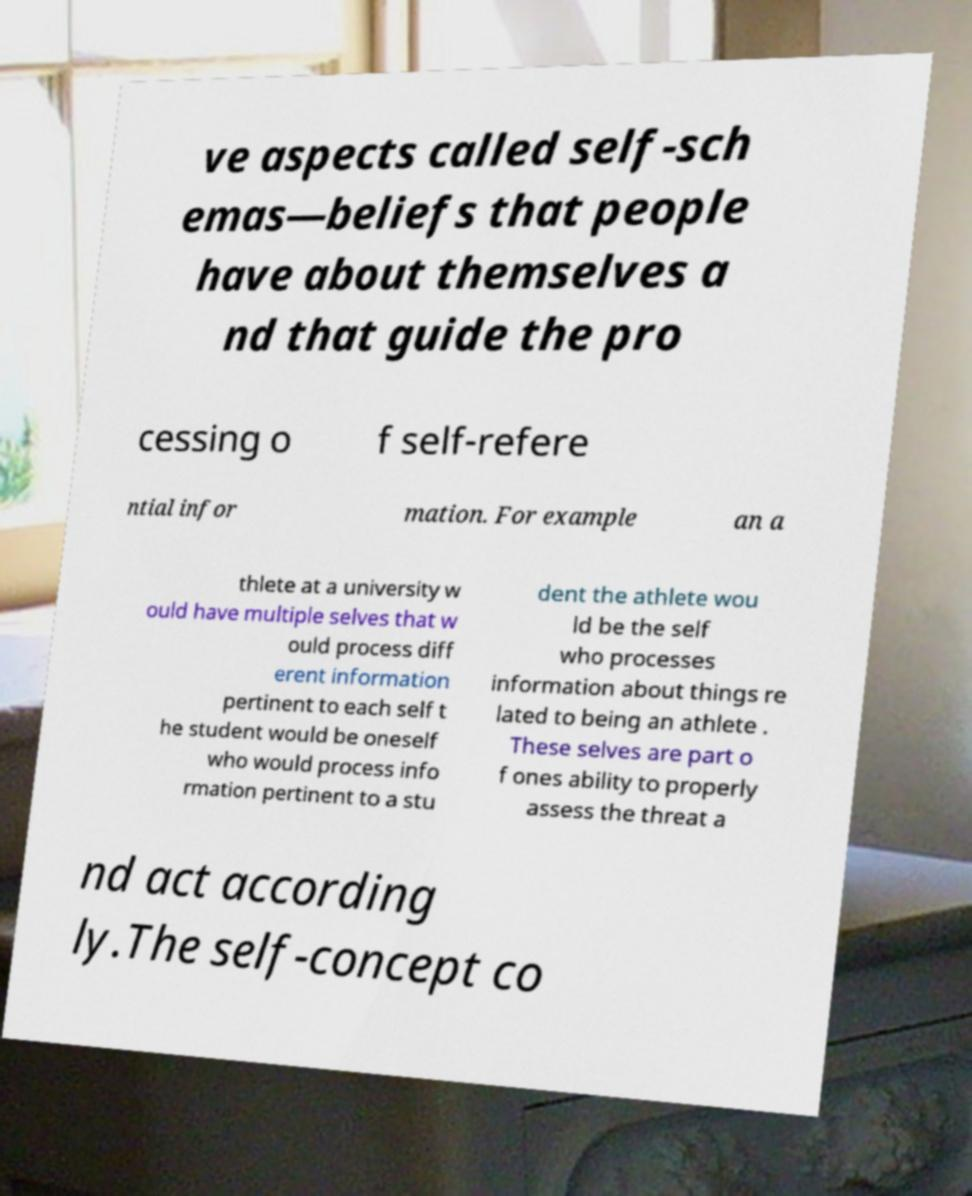Can you read and provide the text displayed in the image?This photo seems to have some interesting text. Can you extract and type it out for me? ve aspects called self-sch emas—beliefs that people have about themselves a nd that guide the pro cessing o f self-refere ntial infor mation. For example an a thlete at a university w ould have multiple selves that w ould process diff erent information pertinent to each self t he student would be oneself who would process info rmation pertinent to a stu dent the athlete wou ld be the self who processes information about things re lated to being an athlete . These selves are part o f ones ability to properly assess the threat a nd act according ly.The self-concept co 